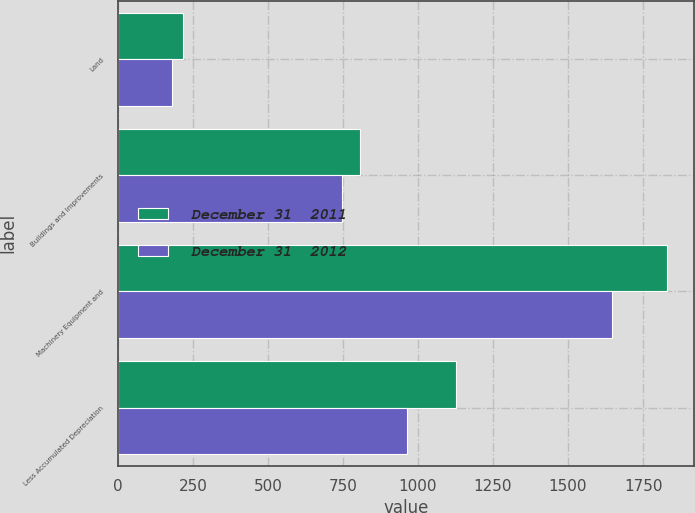Convert chart to OTSL. <chart><loc_0><loc_0><loc_500><loc_500><stacked_bar_chart><ecel><fcel>Land<fcel>Buildings and Improvements<fcel>Machinery Equipment and<fcel>Less Accumulated Depreciation<nl><fcel>December 31  2011<fcel>216.6<fcel>805.5<fcel>1829.9<fcel>1125.6<nl><fcel>December 31  2012<fcel>179.9<fcel>747.4<fcel>1647.6<fcel>963.6<nl></chart> 